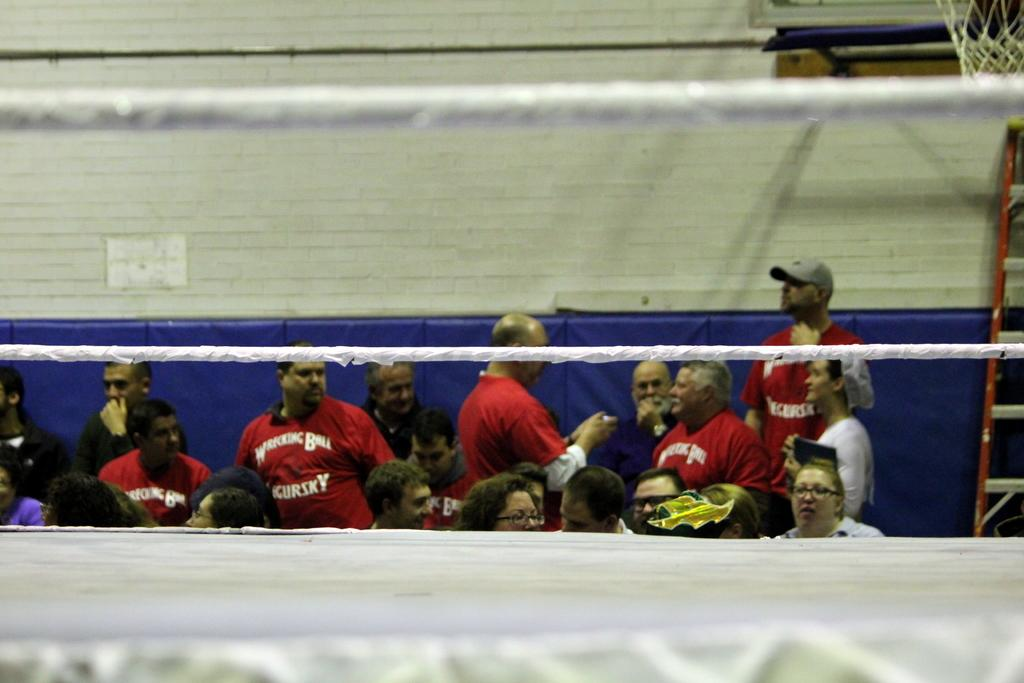What can be seen in the background of the image? There are persons standing in front of the wall. What is located in the foreground of the image? There are rods in the foreground. What type of bread can be seen on the wall in the image? There is no bread present in the image; it only features persons standing in front of the wall and rods in the foreground. Can you tell me how many potatoes are on the rods in the image? There are no potatoes present in the image; only rods can be seen in the foreground. 